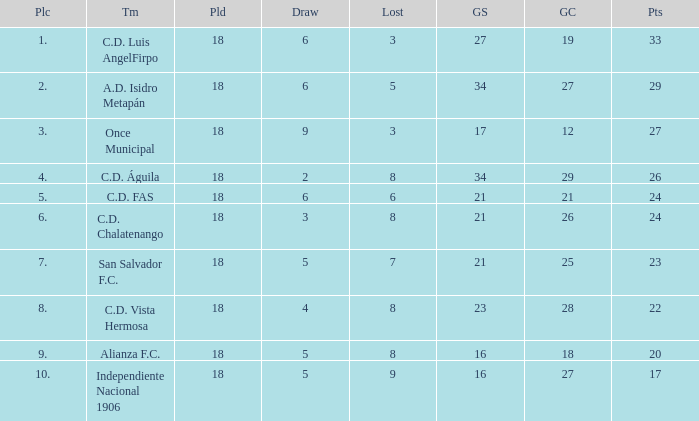What are the number of goals conceded that has a played greater than 18? 0.0. 